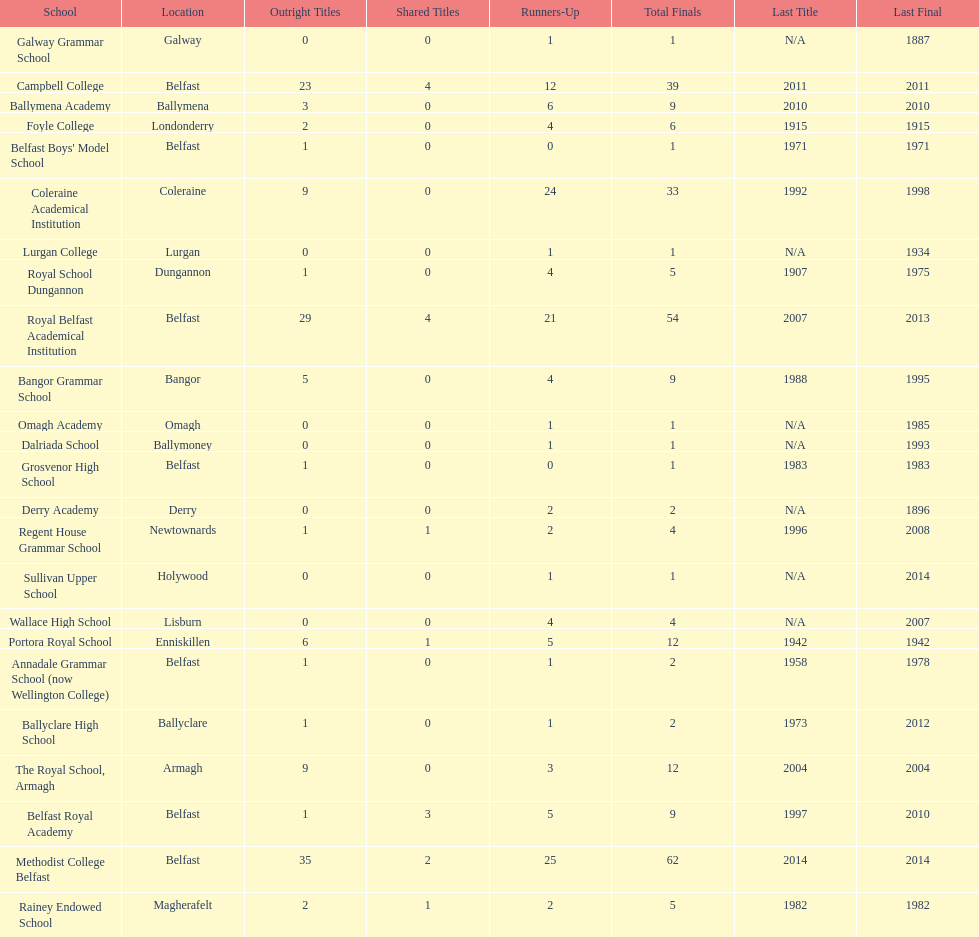Which school has the same number of outright titles as the coleraine academical institution? The Royal School, Armagh. 